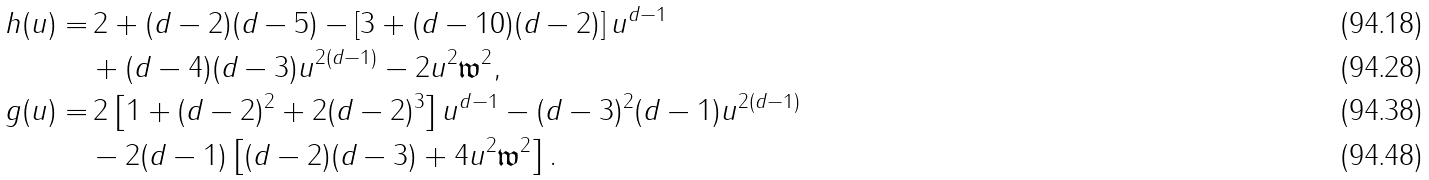Convert formula to latex. <formula><loc_0><loc_0><loc_500><loc_500>h ( u ) = & \, 2 + ( d - 2 ) ( d - 5 ) - \left [ 3 + ( d - 1 0 ) ( d - 2 ) \right ] u ^ { d - 1 } \\ & + ( d - 4 ) ( d - 3 ) u ^ { 2 ( d - 1 ) } - 2 u ^ { 2 } \mathfrak { w } ^ { 2 } , \\ g ( u ) = & \, 2 \left [ 1 + ( d - 2 ) ^ { 2 } + 2 ( d - 2 ) ^ { 3 } \right ] u ^ { d - 1 } - ( d - 3 ) ^ { 2 } ( d - 1 ) u ^ { 2 ( d - 1 ) } \\ & - 2 ( d - 1 ) \left [ ( d - 2 ) ( d - 3 ) + 4 u ^ { 2 } \mathfrak { w } ^ { 2 } \right ] .</formula> 